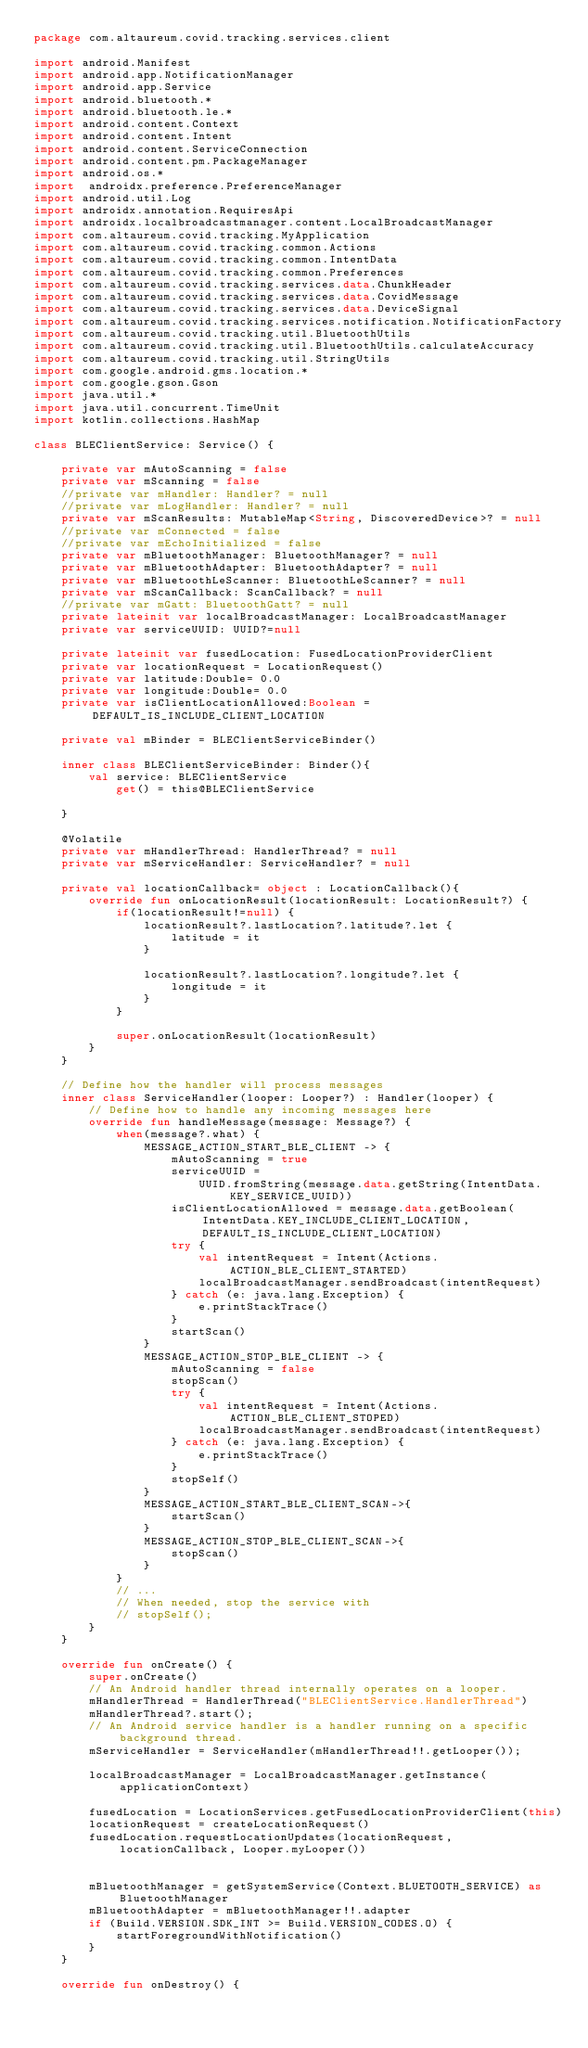<code> <loc_0><loc_0><loc_500><loc_500><_Kotlin_>package com.altaureum.covid.tracking.services.client

import android.Manifest
import android.app.NotificationManager
import android.app.Service
import android.bluetooth.*
import android.bluetooth.le.*
import android.content.Context
import android.content.Intent
import android.content.ServiceConnection
import android.content.pm.PackageManager
import android.os.*
import 	androidx.preference.PreferenceManager
import android.util.Log
import androidx.annotation.RequiresApi
import androidx.localbroadcastmanager.content.LocalBroadcastManager
import com.altaureum.covid.tracking.MyApplication
import com.altaureum.covid.tracking.common.Actions
import com.altaureum.covid.tracking.common.IntentData
import com.altaureum.covid.tracking.common.Preferences
import com.altaureum.covid.tracking.services.data.ChunkHeader
import com.altaureum.covid.tracking.services.data.CovidMessage
import com.altaureum.covid.tracking.services.data.DeviceSignal
import com.altaureum.covid.tracking.services.notification.NotificationFactory
import com.altaureum.covid.tracking.util.BluetoothUtils
import com.altaureum.covid.tracking.util.BluetoothUtils.calculateAccuracy
import com.altaureum.covid.tracking.util.StringUtils
import com.google.android.gms.location.*
import com.google.gson.Gson
import java.util.*
import java.util.concurrent.TimeUnit
import kotlin.collections.HashMap

class BLEClientService: Service() {

    private var mAutoScanning = false
    private var mScanning = false
    //private var mHandler: Handler? = null
    //private var mLogHandler: Handler? = null
    private var mScanResults: MutableMap<String, DiscoveredDevice>? = null
    //private var mConnected = false
    //private var mEchoInitialized = false
    private var mBluetoothManager: BluetoothManager? = null
    private var mBluetoothAdapter: BluetoothAdapter? = null
    private var mBluetoothLeScanner: BluetoothLeScanner? = null
    private var mScanCallback: ScanCallback? = null
    //private var mGatt: BluetoothGatt? = null
    private lateinit var localBroadcastManager: LocalBroadcastManager
    private var serviceUUID: UUID?=null

    private lateinit var fusedLocation: FusedLocationProviderClient
    private var locationRequest = LocationRequest()
    private var latitude:Double= 0.0
    private var longitude:Double= 0.0
    private var isClientLocationAllowed:Boolean = DEFAULT_IS_INCLUDE_CLIENT_LOCATION

    private val mBinder = BLEClientServiceBinder()

    inner class BLEClientServiceBinder: Binder(){
        val service: BLEClientService
            get() = this@BLEClientService

    }

    @Volatile
    private var mHandlerThread: HandlerThread? = null
    private var mServiceHandler: ServiceHandler? = null

    private val locationCallback= object : LocationCallback(){
        override fun onLocationResult(locationResult: LocationResult?) {
            if(locationResult!=null) {
                locationResult?.lastLocation?.latitude?.let {
                    latitude = it
                }

                locationResult?.lastLocation?.longitude?.let {
                    longitude = it
                }
            }

            super.onLocationResult(locationResult)
        }
    }

    // Define how the handler will process messages
    inner class ServiceHandler(looper: Looper?) : Handler(looper) {
        // Define how to handle any incoming messages here
        override fun handleMessage(message: Message?) {
            when(message?.what) {
                MESSAGE_ACTION_START_BLE_CLIENT -> {
                    mAutoScanning = true
                    serviceUUID =
                        UUID.fromString(message.data.getString(IntentData.KEY_SERVICE_UUID))
                    isClientLocationAllowed = message.data.getBoolean(IntentData.KEY_INCLUDE_CLIENT_LOCATION, DEFAULT_IS_INCLUDE_CLIENT_LOCATION)
                    try {
                        val intentRequest = Intent(Actions.ACTION_BLE_CLIENT_STARTED)
                        localBroadcastManager.sendBroadcast(intentRequest)
                    } catch (e: java.lang.Exception) {
                        e.printStackTrace()
                    }
                    startScan()
                }
                MESSAGE_ACTION_STOP_BLE_CLIENT -> {
                    mAutoScanning = false
                    stopScan()
                    try {
                        val intentRequest = Intent(Actions.ACTION_BLE_CLIENT_STOPED)
                        localBroadcastManager.sendBroadcast(intentRequest)
                    } catch (e: java.lang.Exception) {
                        e.printStackTrace()
                    }
                    stopSelf()
                }
                MESSAGE_ACTION_START_BLE_CLIENT_SCAN->{
                    startScan()
                }
                MESSAGE_ACTION_STOP_BLE_CLIENT_SCAN->{
                    stopScan()
                }
            }
            // ...
            // When needed, stop the service with
            // stopSelf();
        }
    }

    override fun onCreate() {
        super.onCreate()
        // An Android handler thread internally operates on a looper.
        mHandlerThread = HandlerThread("BLEClientService.HandlerThread")
        mHandlerThread?.start();
        // An Android service handler is a handler running on a specific background thread.
        mServiceHandler = ServiceHandler(mHandlerThread!!.getLooper());

        localBroadcastManager = LocalBroadcastManager.getInstance(applicationContext)

        fusedLocation = LocationServices.getFusedLocationProviderClient(this)
        locationRequest = createLocationRequest()
        fusedLocation.requestLocationUpdates(locationRequest, locationCallback, Looper.myLooper())


        mBluetoothManager = getSystemService(Context.BLUETOOTH_SERVICE) as BluetoothManager
        mBluetoothAdapter = mBluetoothManager!!.adapter
        if (Build.VERSION.SDK_INT >= Build.VERSION_CODES.O) {
            startForegroundWithNotification()
        }
    }

    override fun onDestroy() {</code> 